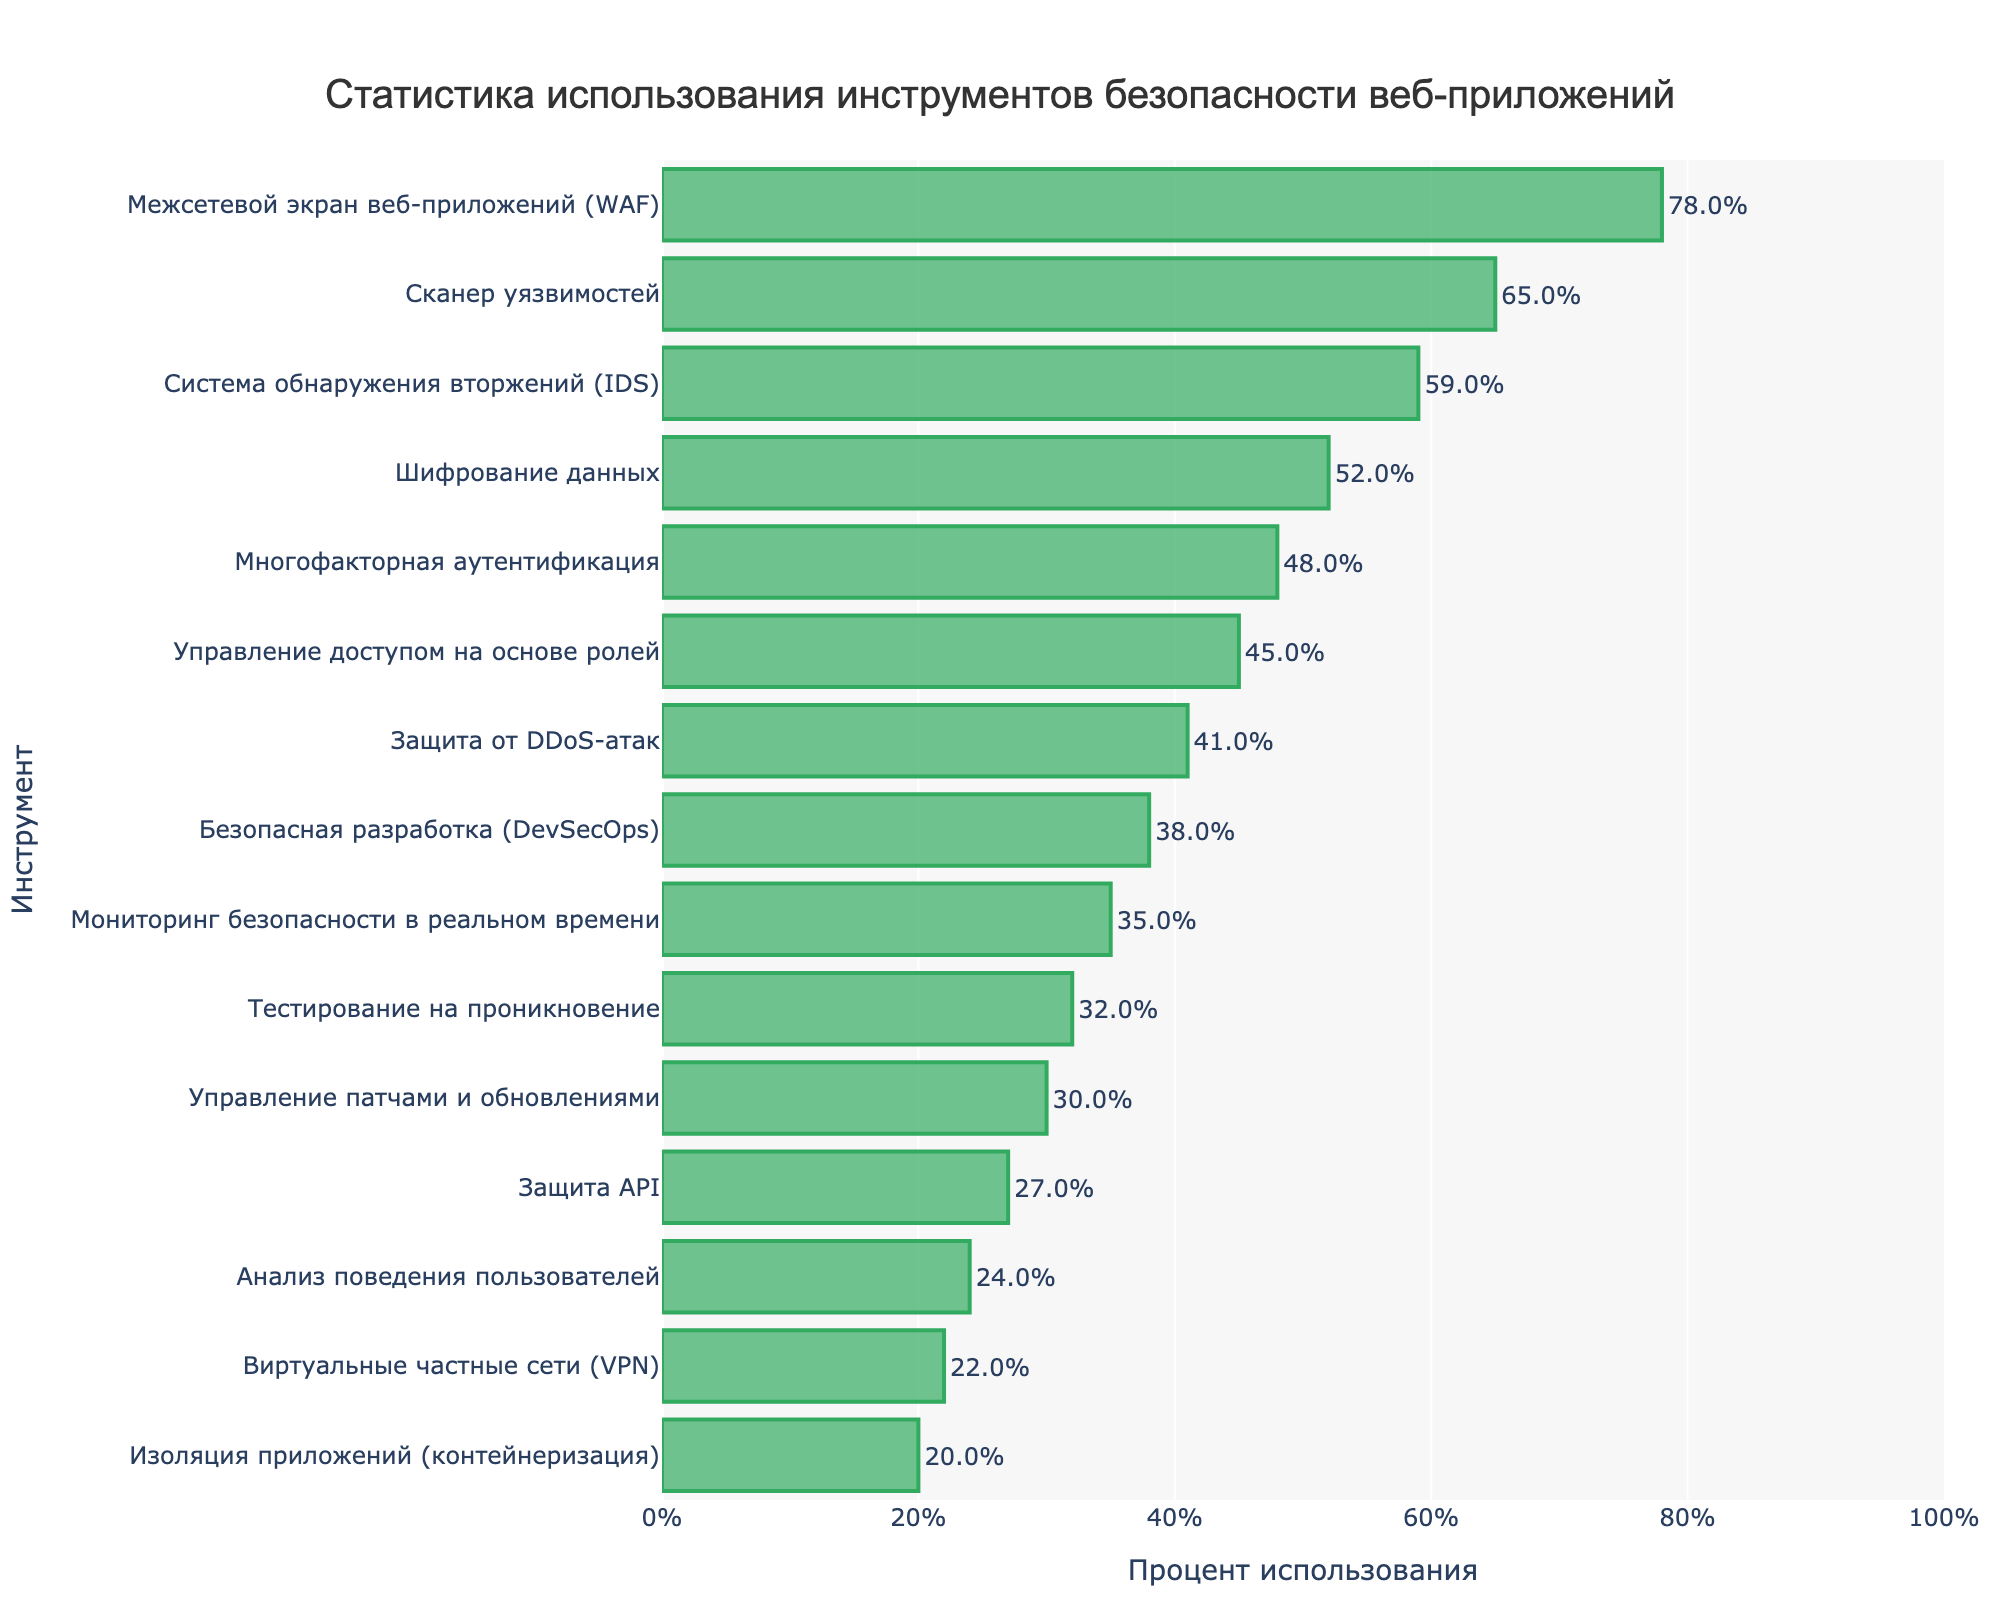Какой инструмент имеет самый высокий процент использования? Самый высокий процент использования показан в первой строке визуализации. На графике видно, что Межсетевой экран веб-приложений (WAF) имеет самый высокий процент - 78%.
Answer: Межсетевой экран веб-приложений (WAF) Какой процент использования у анализа поведения пользователей? Найдите инструмент "Анализ поведения пользователей" на вертикальной оси и посмотрите на длину бара, который его представляет. Процент использования указан рядом с концом бара - это 24%.
Answer: 24% Средний процент использования самых популярных трех инструментов Сначала нужно определить три инструмента с самым высоким процентом использования: Межсетевой экран веб-приложений (WAF) - 78%, Сканер уязвимостей - 65%, Система обнаружения вторжений (IDS) - 59%. Сумма этих значений: 78 + 65 + 59 = 202. Средний процент: 202 / 3 = 67.33
Answer: 67.33 Как соотносятся проценты использования шифрования данных и многофакторной аутентификации? Найдите проценты использования для шифрования данных (52%) и многофакторной аутентификации (48%) на графике и сравните их. Шифрование данных используется чаще.
Answer: Шифрование данных используется чаще Насколько процент использования защиты API меньше, чем процент использования управления патчами и обновлениями? Найдите проценты использования для защиты API (27%) и управления патчами и обновлениями (30%). Разница между ними: 30 - 27 = 3%.
Answer: 3% Суммарный процент использования инструментов, относящихся к аутентификации и авторизации (многофакторная аутентификация и управление доступом на основе ролей) Найдите проценты для многофакторной аутентификации (48%) и управления доступом на основе ролей (45%). Сумма этих значений: 48 + 45 = 93%.
Answer: 93% Какой инструмент имеет процент использования менее 25% и связан с сетевыми технологиями? Найдите инструмент с процентом использования менее 25% и связанный с сетевыми технологиями. На графике видно, что Виртуальные частные сети (VPN) имеют процент использования 22%, и они связаны с сетевыми технологиями.
Answer: Виртуальные частные сети (VPN) На сколько процентов использование управления патчами и обновлениями меньше, чем шифрование данных? Найдите проценты использования для управления патчами и обновлениями (30%) и шифрование данных (52%). Разница: 52 - 30 = 22%.
Answer: 22% 